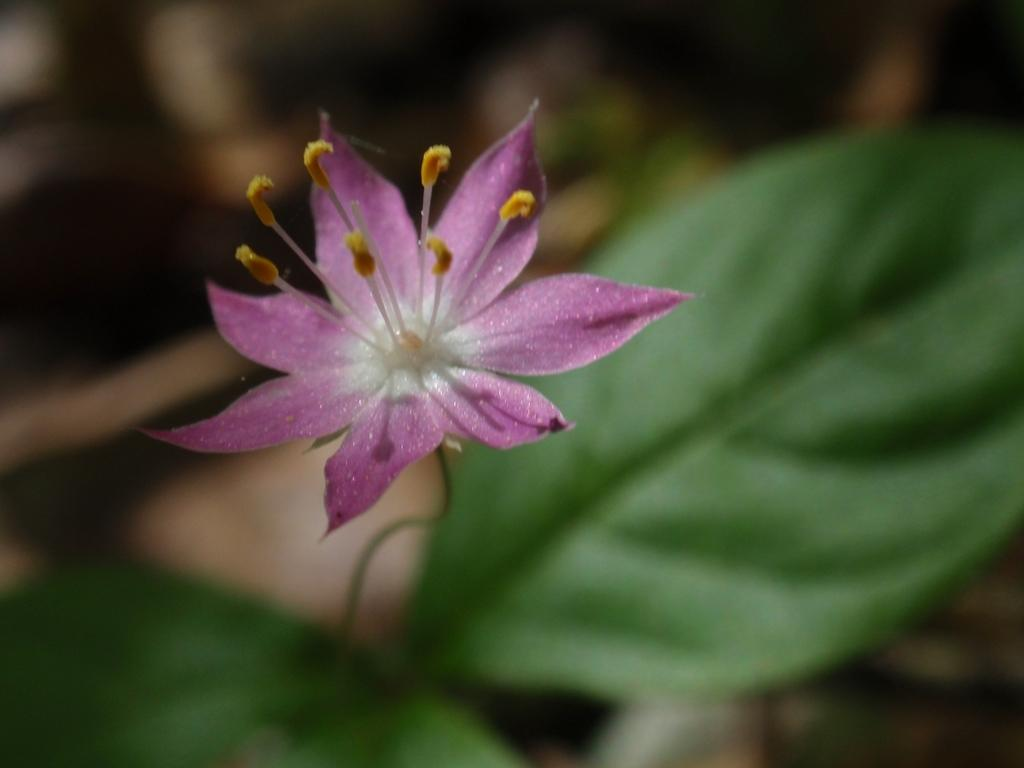What type of plant is visible in the image? The image features a plant with a flower on its stem. Can you describe the flower in the image? The flower is on the stem of the plant. What type of chain can be seen connecting the flower to the plant in the image? There is no chain present in the image; the flower is naturally connected to the plant through its stem. 